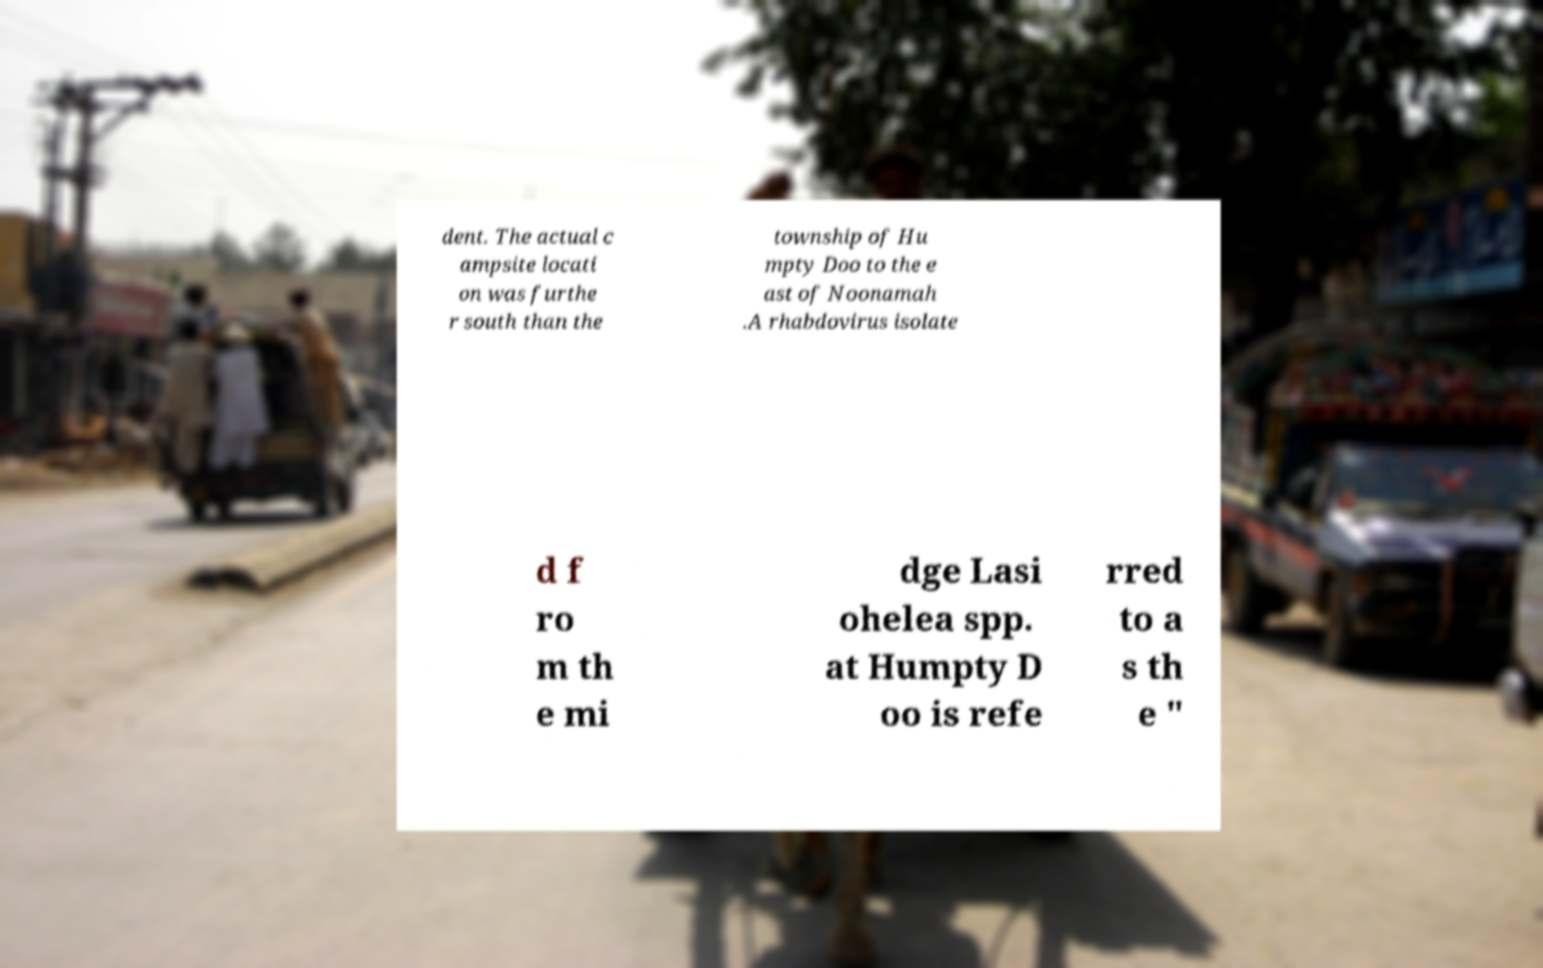There's text embedded in this image that I need extracted. Can you transcribe it verbatim? dent. The actual c ampsite locati on was furthe r south than the township of Hu mpty Doo to the e ast of Noonamah .A rhabdovirus isolate d f ro m th e mi dge Lasi ohelea spp. at Humpty D oo is refe rred to a s th e " 